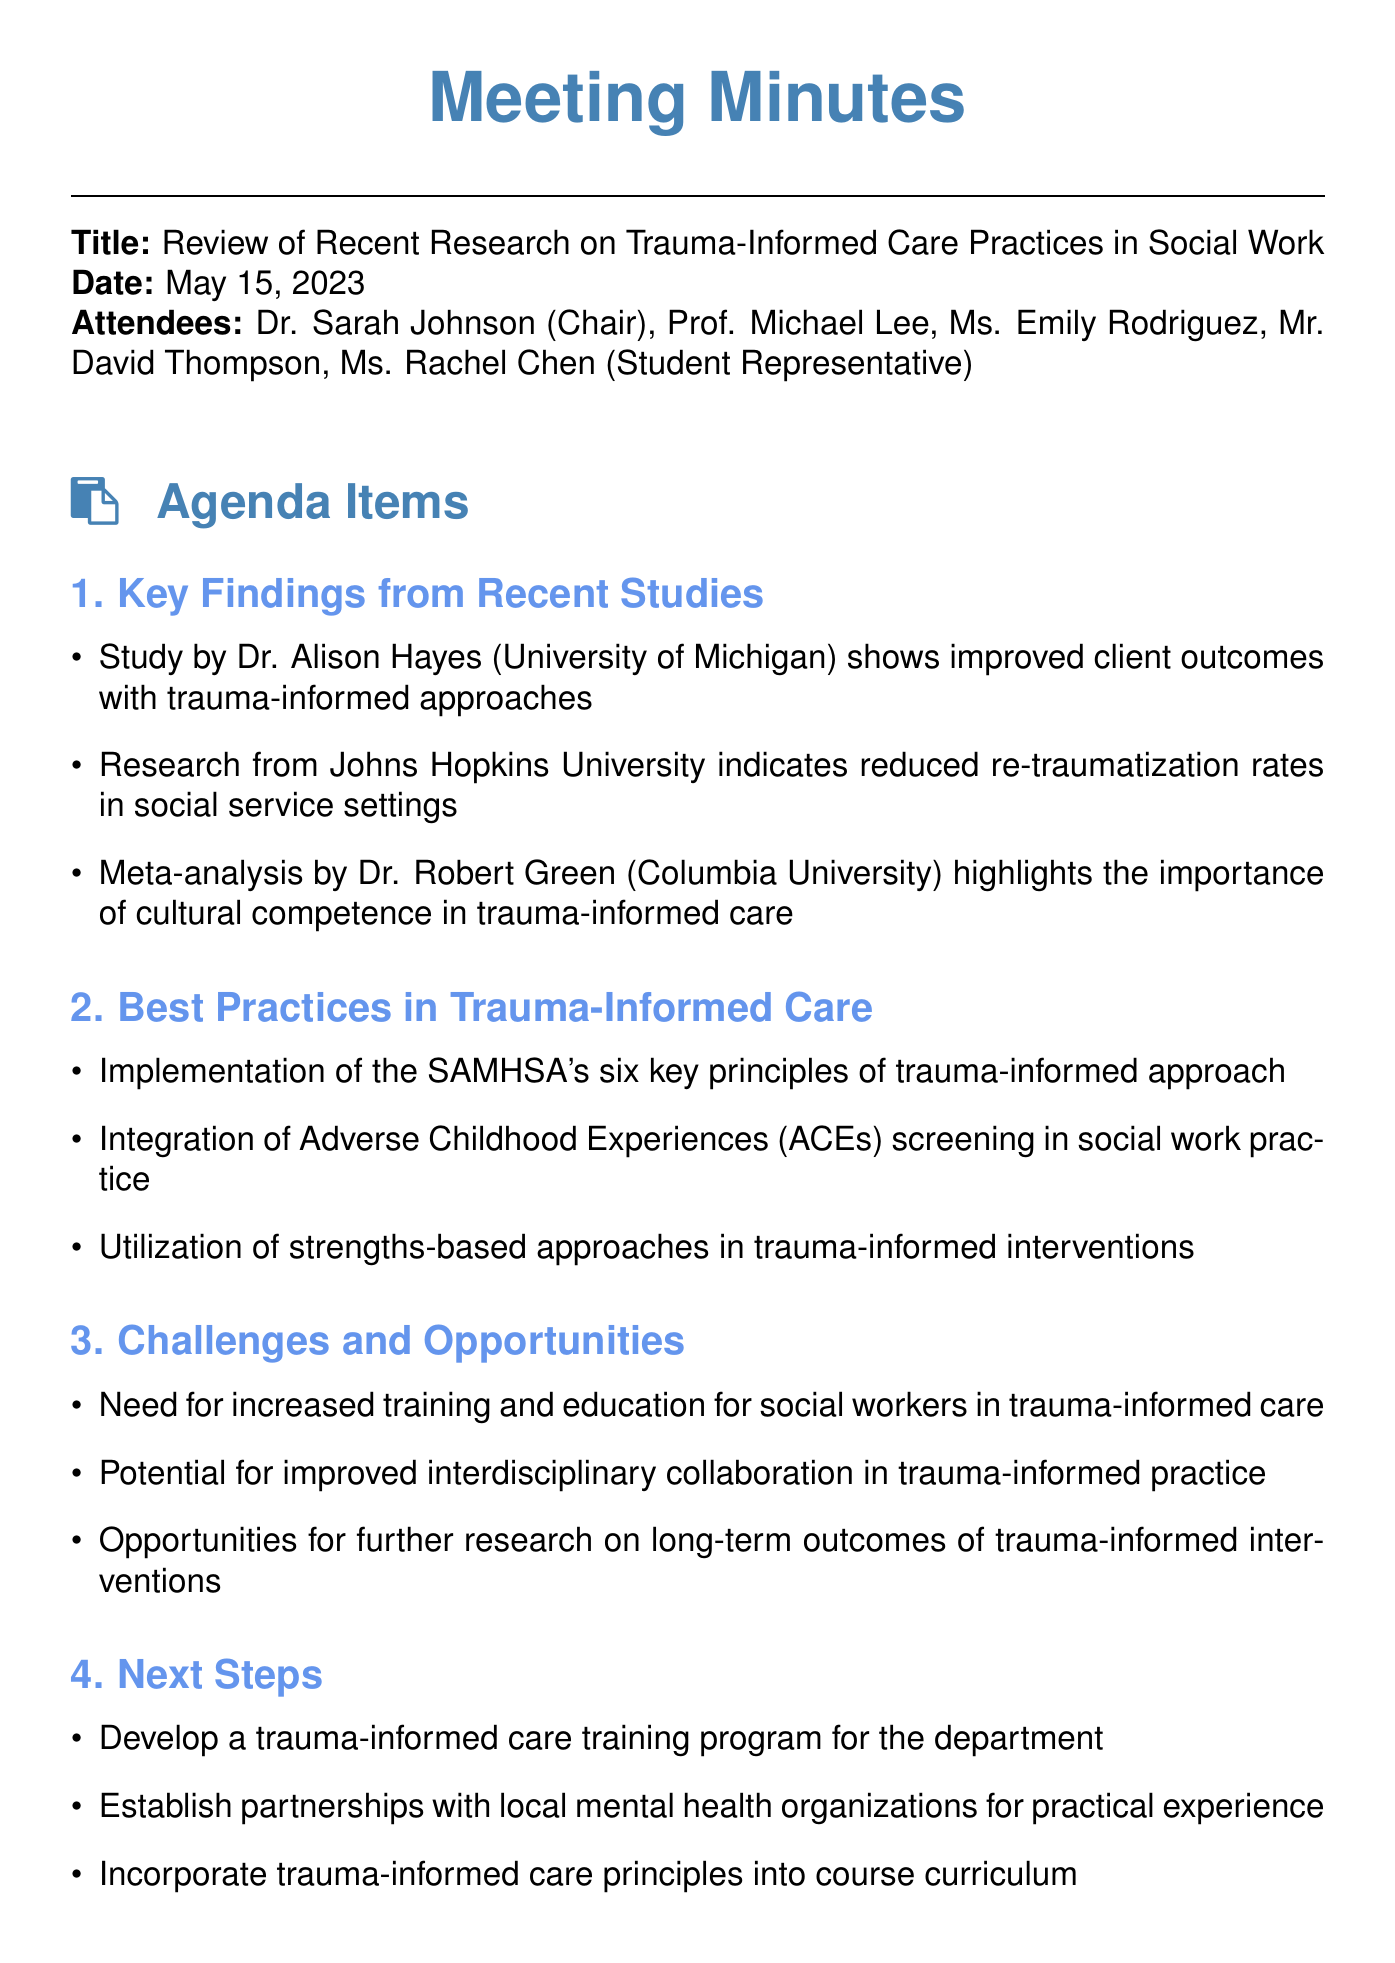What is the date of the meeting? The date of the meeting is specifically noted in the document, which is May 15, 2023.
Answer: May 15, 2023 Who chaired the meeting? The chairperson of the meeting is mentioned at the beginning of the document as Dr. Sarah Johnson.
Answer: Dr. Sarah Johnson Which university conducted a study showing improved client outcomes? The document lists a study conducted by Dr. Alison Hayes at the University of Michigan that found improved client outcomes.
Answer: University of Michigan What is one of the key principles of trauma-informed care mentioned? The document specifies that the SAMHSA's six key principles of trauma-informed approach is one of the best practices discussed.
Answer: SAMHSA's six key principles What opportunity is mentioned for improving social work practices? The document states that there is potential for improved interdisciplinary collaboration in trauma-informed practice.
Answer: Improved interdisciplinary collaboration Who is responsible for compiling a list of recommended readings? The action item indicates that Rachel Chen will compile a list of recommended readings on trauma-informed care for students.
Answer: Rachel Chen What is one of the best practices in trauma-informed care? The document outlines the integration of Adverse Childhood Experiences (ACEs) screening as a best practice in trauma-informed care.
Answer: Integration of ACEs screening What is one action item to enhance practical experience? The document mentions the establishment of partnerships with local mental health organizations as a practical experience opportunity.
Answer: Partnerships with local mental health organizations 